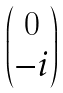<formula> <loc_0><loc_0><loc_500><loc_500>\begin{pmatrix} 0 \\ - i \end{pmatrix}</formula> 